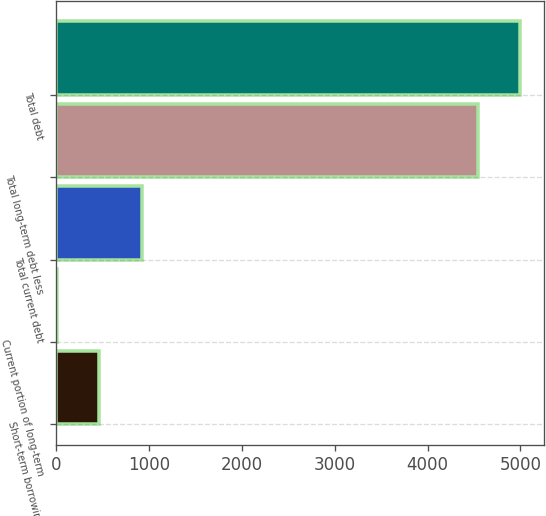Convert chart. <chart><loc_0><loc_0><loc_500><loc_500><bar_chart><fcel>Short-term borrowings<fcel>Current portion of long-term<fcel>Total current debt<fcel>Total long-term debt less<fcel>Total debt<nl><fcel>459.8<fcel>1.8<fcel>917.8<fcel>4540.8<fcel>4998.8<nl></chart> 